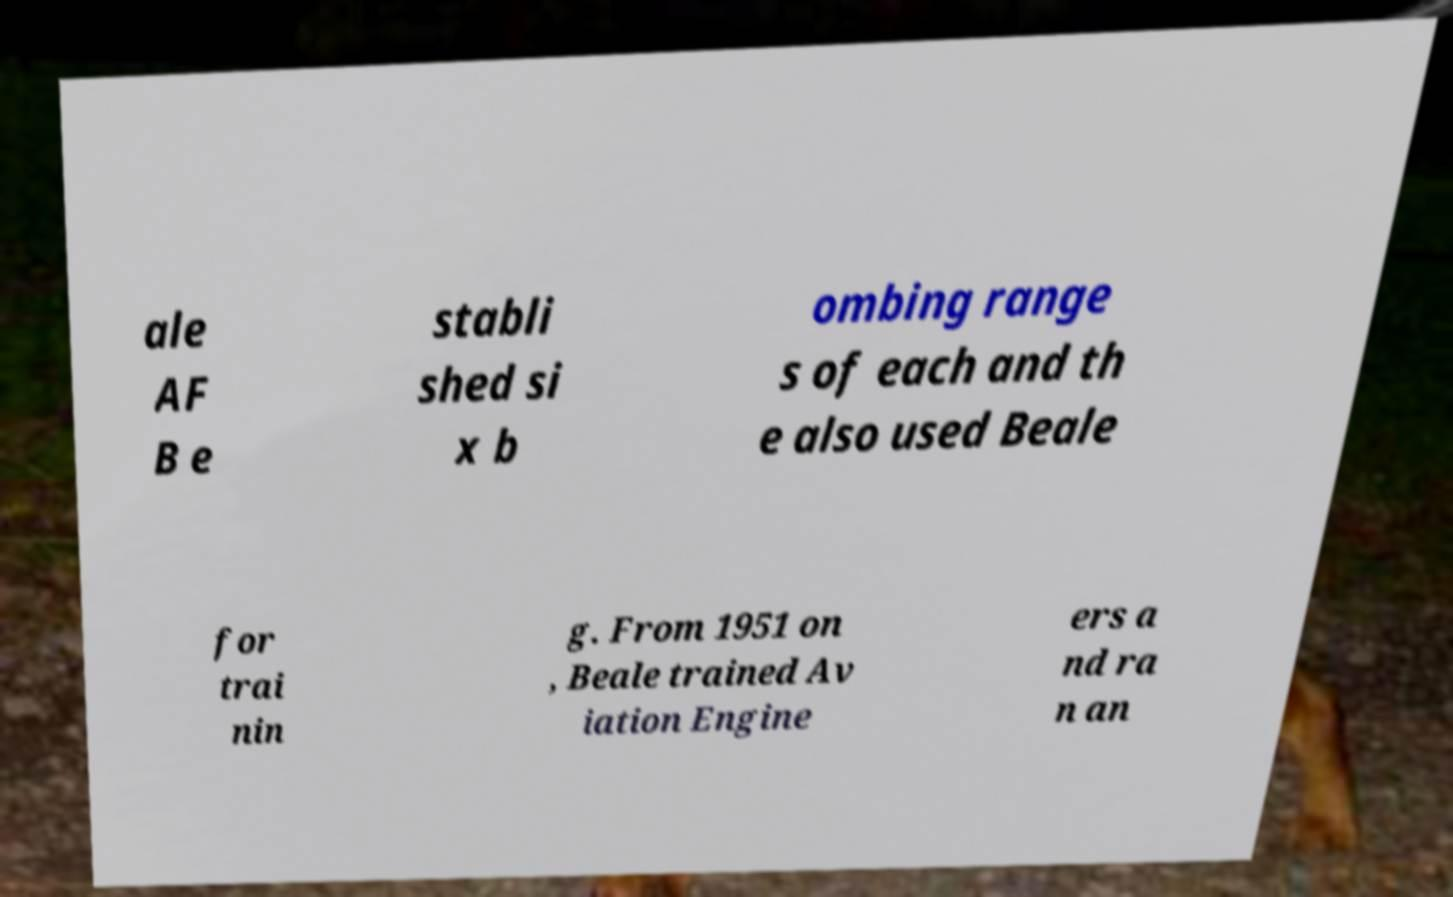I need the written content from this picture converted into text. Can you do that? ale AF B e stabli shed si x b ombing range s of each and th e also used Beale for trai nin g. From 1951 on , Beale trained Av iation Engine ers a nd ra n an 